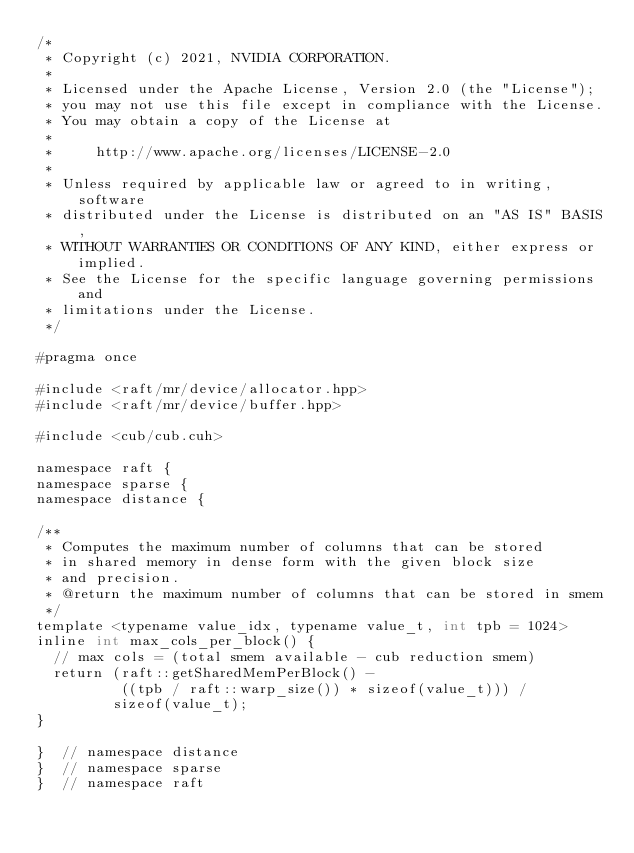<code> <loc_0><loc_0><loc_500><loc_500><_Cuda_>/*
 * Copyright (c) 2021, NVIDIA CORPORATION.
 *
 * Licensed under the Apache License, Version 2.0 (the "License");
 * you may not use this file except in compliance with the License.
 * You may obtain a copy of the License at
 *
 *     http://www.apache.org/licenses/LICENSE-2.0
 *
 * Unless required by applicable law or agreed to in writing, software
 * distributed under the License is distributed on an "AS IS" BASIS,
 * WITHOUT WARRANTIES OR CONDITIONS OF ANY KIND, either express or implied.
 * See the License for the specific language governing permissions and
 * limitations under the License.
 */

#pragma once

#include <raft/mr/device/allocator.hpp>
#include <raft/mr/device/buffer.hpp>

#include <cub/cub.cuh>

namespace raft {
namespace sparse {
namespace distance {

/**
 * Computes the maximum number of columns that can be stored
 * in shared memory in dense form with the given block size
 * and precision.
 * @return the maximum number of columns that can be stored in smem
 */
template <typename value_idx, typename value_t, int tpb = 1024>
inline int max_cols_per_block() {
  // max cols = (total smem available - cub reduction smem)
  return (raft::getSharedMemPerBlock() -
          ((tpb / raft::warp_size()) * sizeof(value_t))) /
         sizeof(value_t);
}

}  // namespace distance
}  // namespace sparse
}  // namespace raft
</code> 